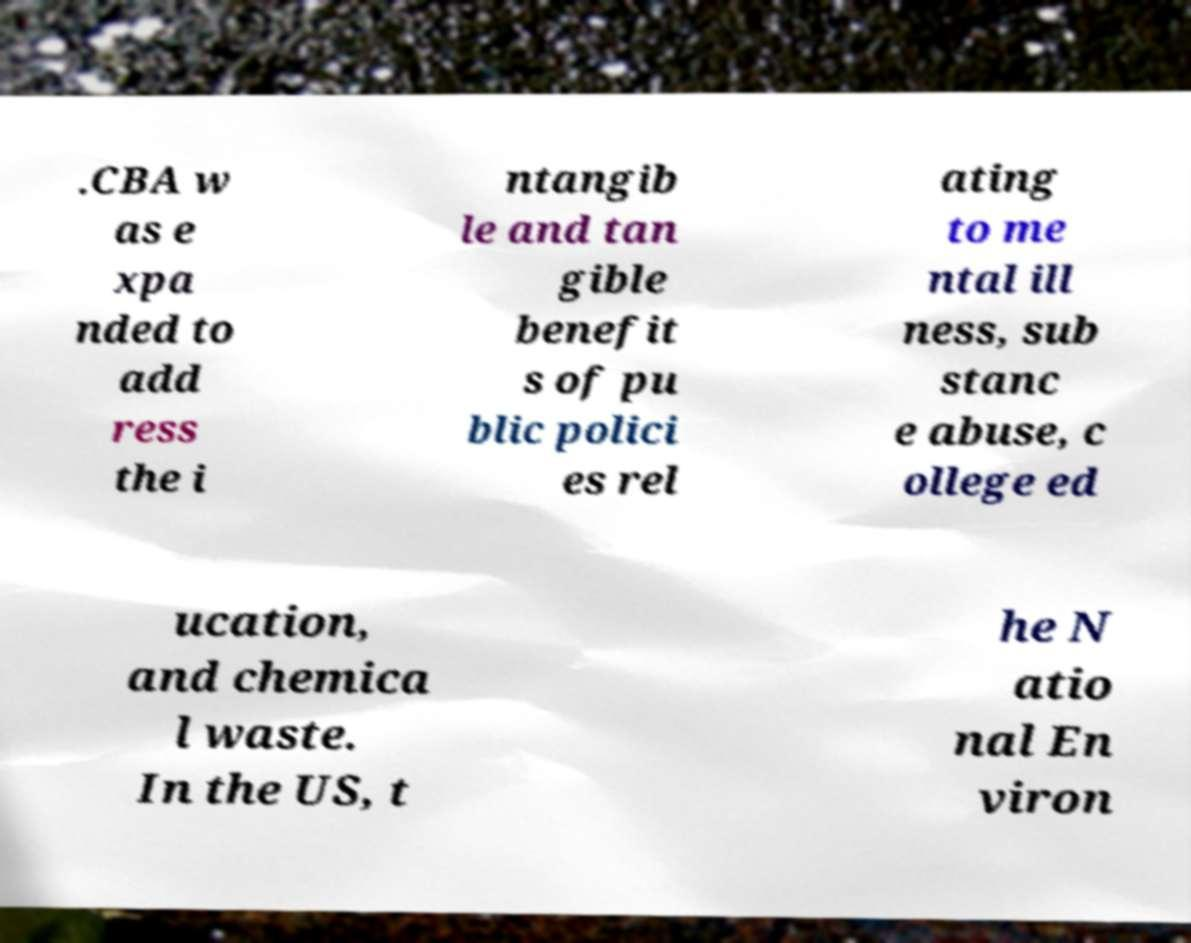What messages or text are displayed in this image? I need them in a readable, typed format. .CBA w as e xpa nded to add ress the i ntangib le and tan gible benefit s of pu blic polici es rel ating to me ntal ill ness, sub stanc e abuse, c ollege ed ucation, and chemica l waste. In the US, t he N atio nal En viron 